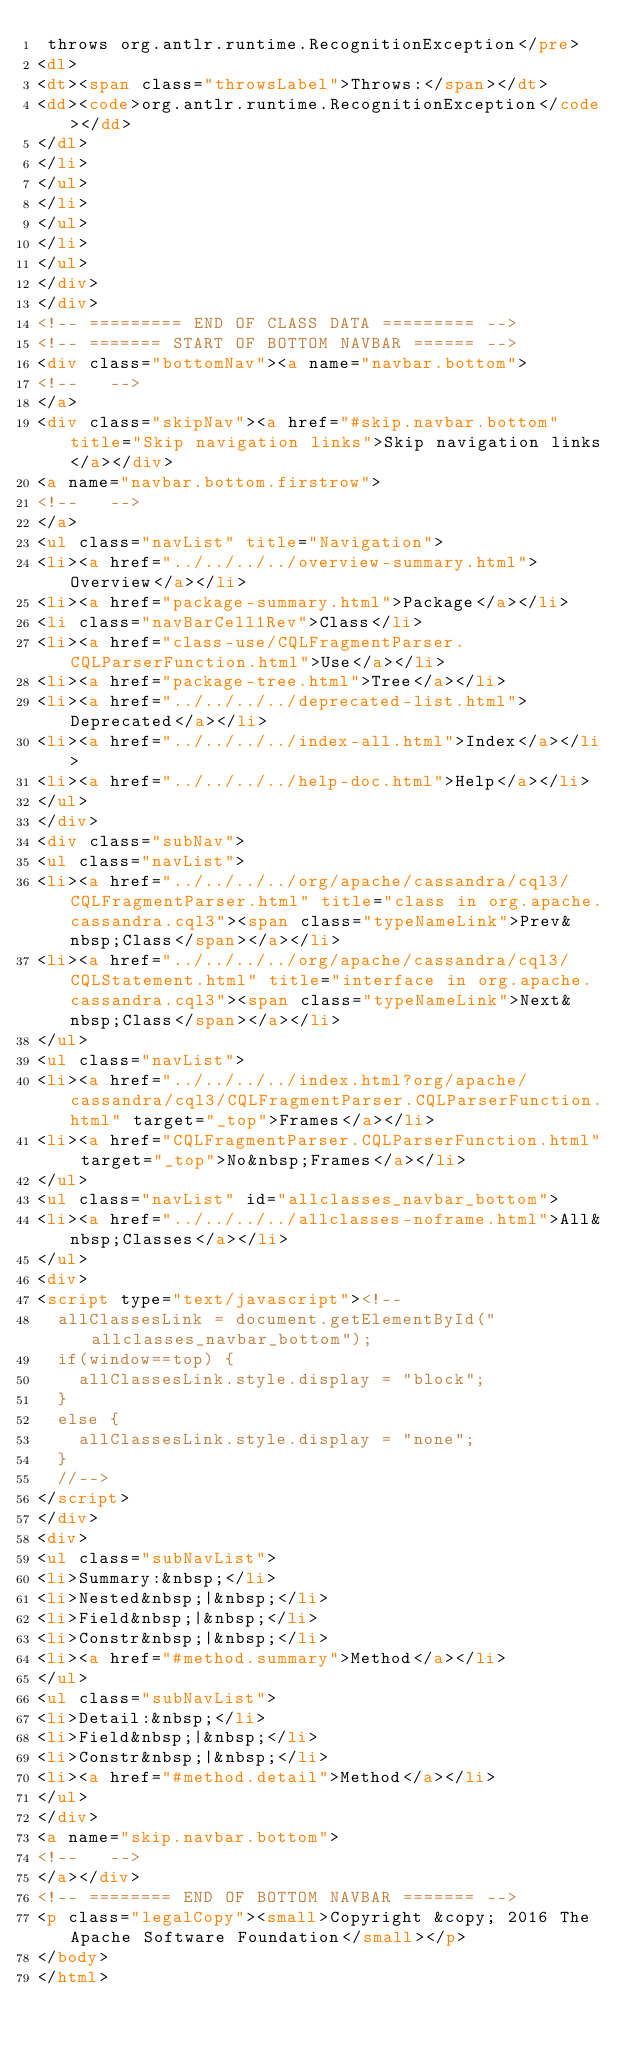<code> <loc_0><loc_0><loc_500><loc_500><_HTML_> throws org.antlr.runtime.RecognitionException</pre>
<dl>
<dt><span class="throwsLabel">Throws:</span></dt>
<dd><code>org.antlr.runtime.RecognitionException</code></dd>
</dl>
</li>
</ul>
</li>
</ul>
</li>
</ul>
</div>
</div>
<!-- ========= END OF CLASS DATA ========= -->
<!-- ======= START OF BOTTOM NAVBAR ====== -->
<div class="bottomNav"><a name="navbar.bottom">
<!--   -->
</a>
<div class="skipNav"><a href="#skip.navbar.bottom" title="Skip navigation links">Skip navigation links</a></div>
<a name="navbar.bottom.firstrow">
<!--   -->
</a>
<ul class="navList" title="Navigation">
<li><a href="../../../../overview-summary.html">Overview</a></li>
<li><a href="package-summary.html">Package</a></li>
<li class="navBarCell1Rev">Class</li>
<li><a href="class-use/CQLFragmentParser.CQLParserFunction.html">Use</a></li>
<li><a href="package-tree.html">Tree</a></li>
<li><a href="../../../../deprecated-list.html">Deprecated</a></li>
<li><a href="../../../../index-all.html">Index</a></li>
<li><a href="../../../../help-doc.html">Help</a></li>
</ul>
</div>
<div class="subNav">
<ul class="navList">
<li><a href="../../../../org/apache/cassandra/cql3/CQLFragmentParser.html" title="class in org.apache.cassandra.cql3"><span class="typeNameLink">Prev&nbsp;Class</span></a></li>
<li><a href="../../../../org/apache/cassandra/cql3/CQLStatement.html" title="interface in org.apache.cassandra.cql3"><span class="typeNameLink">Next&nbsp;Class</span></a></li>
</ul>
<ul class="navList">
<li><a href="../../../../index.html?org/apache/cassandra/cql3/CQLFragmentParser.CQLParserFunction.html" target="_top">Frames</a></li>
<li><a href="CQLFragmentParser.CQLParserFunction.html" target="_top">No&nbsp;Frames</a></li>
</ul>
<ul class="navList" id="allclasses_navbar_bottom">
<li><a href="../../../../allclasses-noframe.html">All&nbsp;Classes</a></li>
</ul>
<div>
<script type="text/javascript"><!--
  allClassesLink = document.getElementById("allclasses_navbar_bottom");
  if(window==top) {
    allClassesLink.style.display = "block";
  }
  else {
    allClassesLink.style.display = "none";
  }
  //-->
</script>
</div>
<div>
<ul class="subNavList">
<li>Summary:&nbsp;</li>
<li>Nested&nbsp;|&nbsp;</li>
<li>Field&nbsp;|&nbsp;</li>
<li>Constr&nbsp;|&nbsp;</li>
<li><a href="#method.summary">Method</a></li>
</ul>
<ul class="subNavList">
<li>Detail:&nbsp;</li>
<li>Field&nbsp;|&nbsp;</li>
<li>Constr&nbsp;|&nbsp;</li>
<li><a href="#method.detail">Method</a></li>
</ul>
</div>
<a name="skip.navbar.bottom">
<!--   -->
</a></div>
<!-- ======== END OF BOTTOM NAVBAR ======= -->
<p class="legalCopy"><small>Copyright &copy; 2016 The Apache Software Foundation</small></p>
</body>
</html>
</code> 